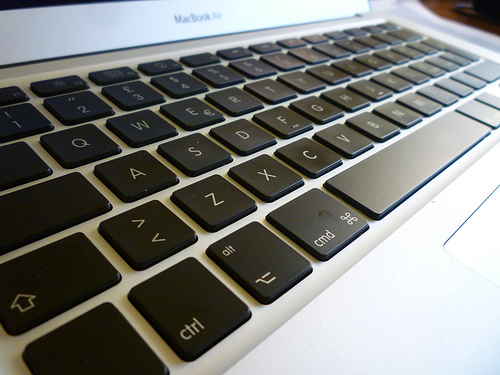<image>
Is the keyboard on the table? Yes. Looking at the image, I can see the keyboard is positioned on top of the table, with the table providing support. 